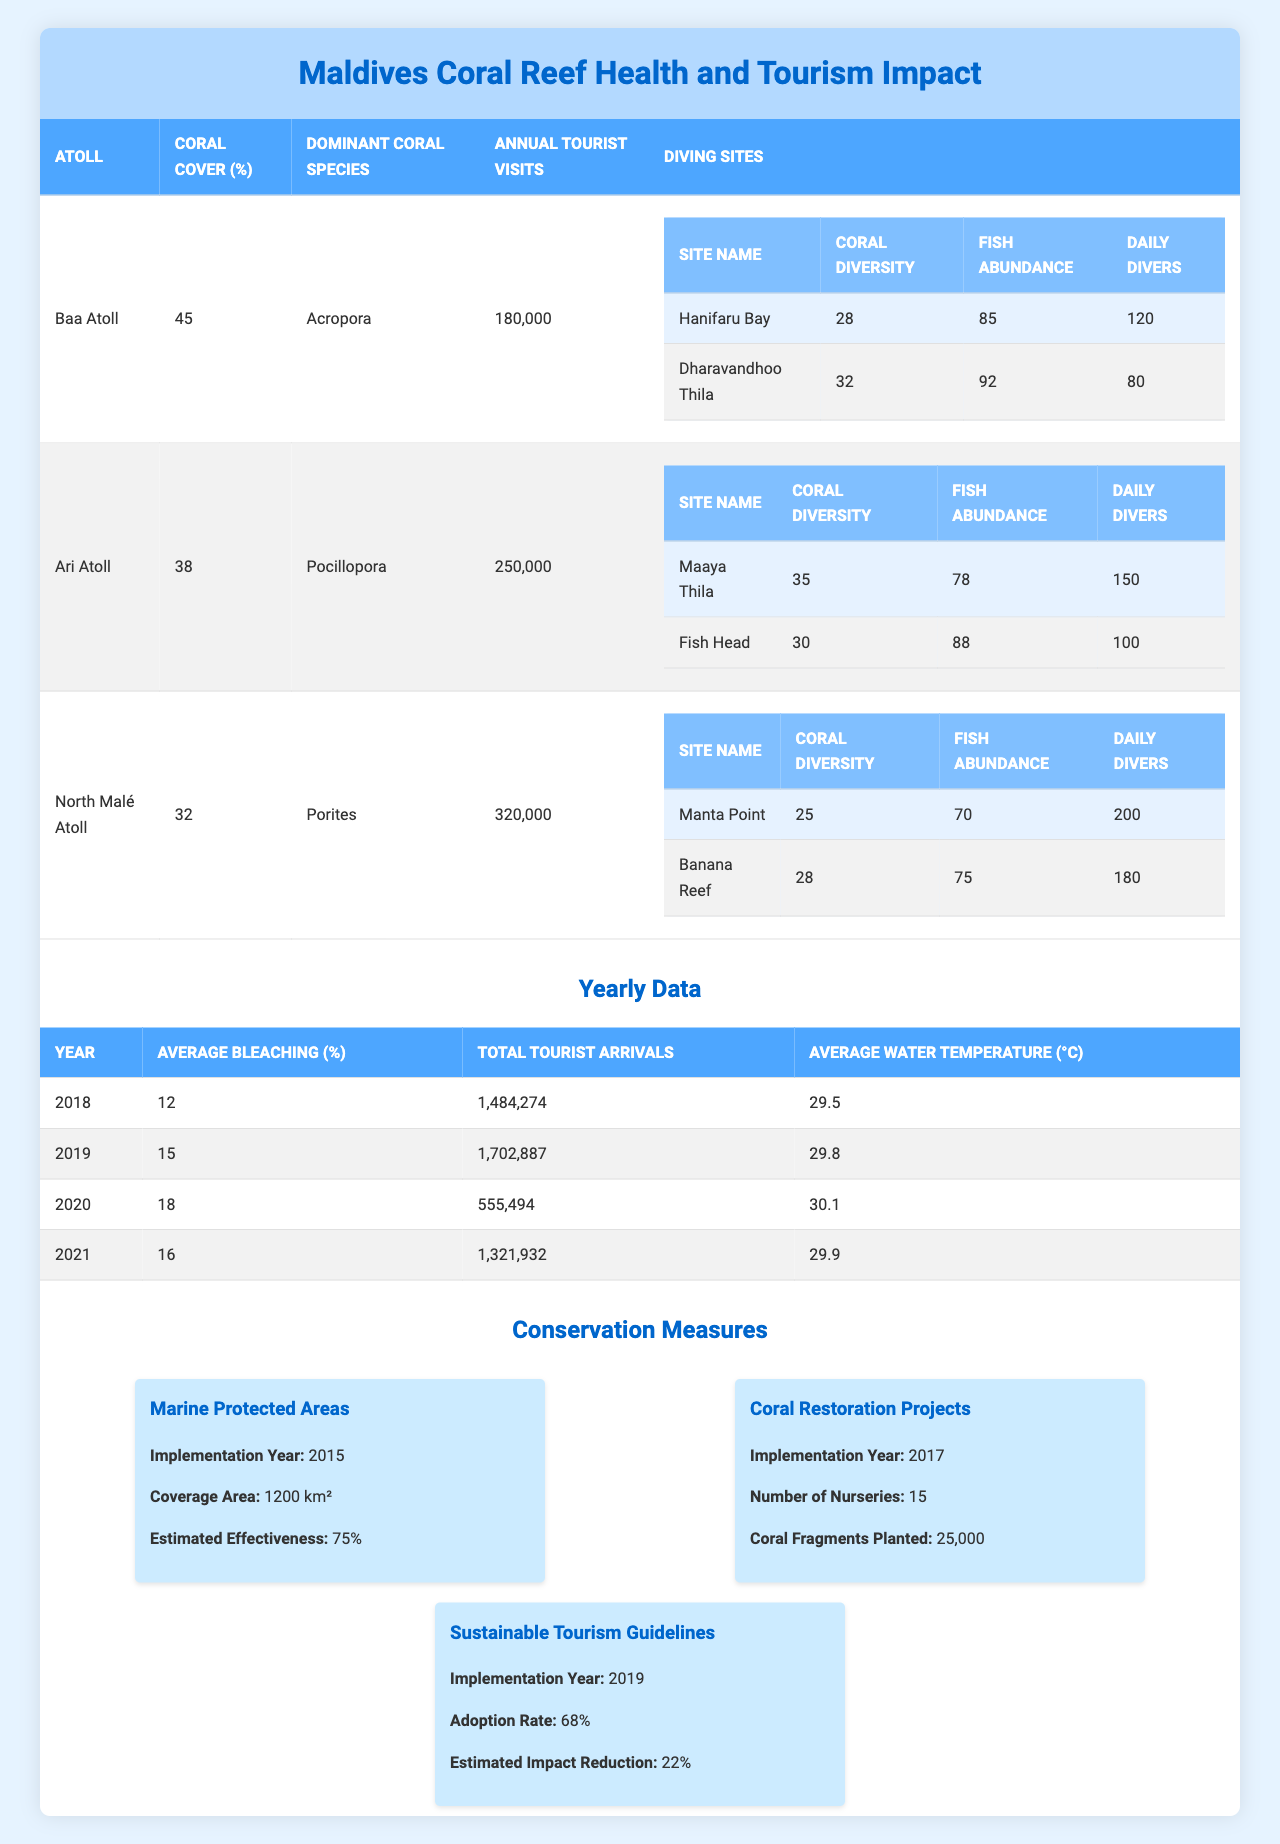What is the dominant coral species in Baa Atoll? In the table under the "Atoll" section, Baa Atoll has "Acropora" listed as its dominant coral species.
Answer: Acropora How many annual tourist visits does North Malé Atoll receive? The annual tourist visits for North Malé Atoll are shown in the table as 320,000.
Answer: 320,000 What is the average bleaching percentage in 2019? Referring to the yearly data in the table, the average bleaching percentage for the year 2019 is 15%.
Answer: 15% Which atoll has the highest coral cover percentage? By comparing the "Coral Cover (%)" column across all atolls, Baa Atoll has the highest percentage at 45%.
Answer: Baa Atoll What is the total number of daily divers at the Maaya Thila diving site? The daily divers for Maaya Thila are listed in the diving sites section under Ari Atoll as 150.
Answer: 150 In which year did the average water temperature reach 30.1°C? The yearly data indicates that the average water temperature of 30.1°C occurred in 2020.
Answer: 2020 Is the adoption rate of sustainable tourism guidelines above 70%? The table shows the adoption rate for sustainable tourism guidelines is 68%, which is below 70%.
Answer: No Which atoll has the lowest coral cover percentage, and what is it? By examining the coral cover percentages of all atolls, North Malé Atoll has the lowest percentage at 32%.
Answer: North Malé Atoll, 32% How would you calculate the total number of daily divers across all diving sites in Baa Atoll? To find the total daily divers, add the daily divers for both sites: Hanifaru Bay (120) + Dharavandhoo Thila (80) = 200.
Answer: 200 If annual tourist visits to Ari Atoll increase by 10%, what will the new number of visits be? A 10% increase on the current annual tourist visits (250,000) would be calculated as 250,000 * 0.10 = 25,000. Adding that to the original number gives 250,000 + 25,000 = 275,000.
Answer: 275,000 What is the estimated effectiveness of the Marine Protected Areas set up in 2015? According to the conservation measures section of the table, the estimated effectiveness of the Marine Protected Areas is 75%.
Answer: 75% How many coral fragments were planted as part of coral restoration projects? The table indicates that a total of 25,000 coral fragments were planted during the coral restoration projects.
Answer: 25,000 What was the average tourist arrival in the year 2021 compared to 2018? The total tourist arrivals in 2021 were 1,321,932 and in 2018 it was 1,484,274. The difference can be calculated as 1,484,274 - 1,321,932 = 162,342.
Answer: 162,342 fewer in 2021 Is the average water temperature consistently rising over the years listed? By observing the yearly data, the average water temperature increased from 29.5°C in 2018 to 30.1°C in 2020 before slightly dropping to 29.9°C in 2021, indicating a non-consistent trend.
Answer: No 